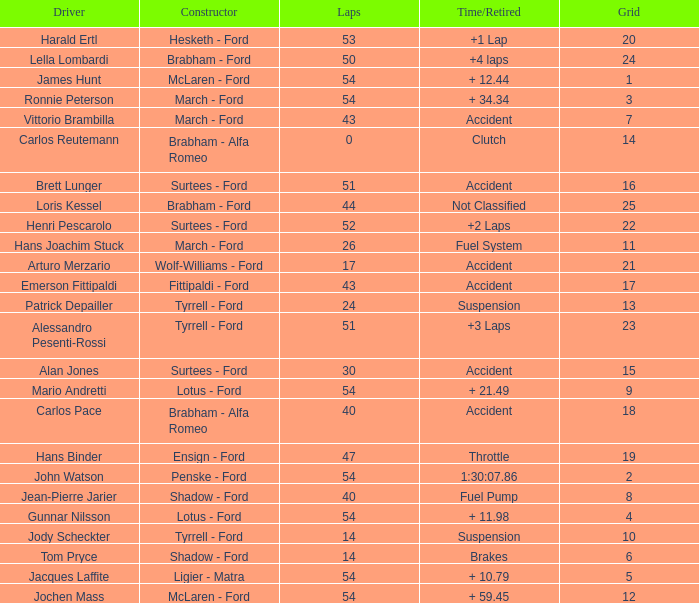What is the Time/Retired of Carlos Reutemann who was driving a brabham - Alfa Romeo? Clutch. 